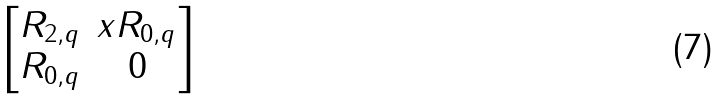Convert formula to latex. <formula><loc_0><loc_0><loc_500><loc_500>\begin{bmatrix} R _ { 2 , q } & x R _ { 0 , q } \\ R _ { 0 , q } & 0 \end{bmatrix}</formula> 